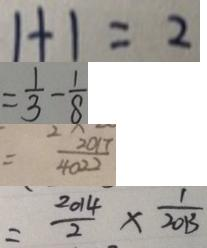Convert formula to latex. <formula><loc_0><loc_0><loc_500><loc_500>1 + 1 = 2 
 = \frac { 1 } { 3 } - \frac { 1 } { 8 } 
 = \frac { 2 0 1 7 } { 4 0 2 2 } 
 = \frac { 2 0 1 4 } { 2 } \times \frac { 1 } { 2 0 1 3 }</formula> 